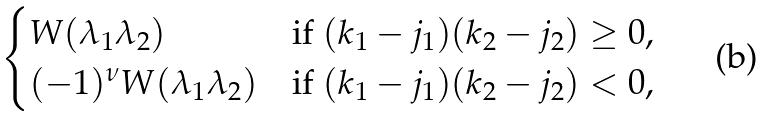Convert formula to latex. <formula><loc_0><loc_0><loc_500><loc_500>\begin{cases} W ( \lambda _ { 1 } \lambda _ { 2 } ) & \text {if } ( k _ { 1 } - j _ { 1 } ) ( k _ { 2 } - j _ { 2 } ) \geq 0 , \\ ( - 1 ) ^ { \nu } W ( \lambda _ { 1 } \lambda _ { 2 } ) & \text {if } ( k _ { 1 } - j _ { 1 } ) ( k _ { 2 } - j _ { 2 } ) < 0 , \end{cases}</formula> 